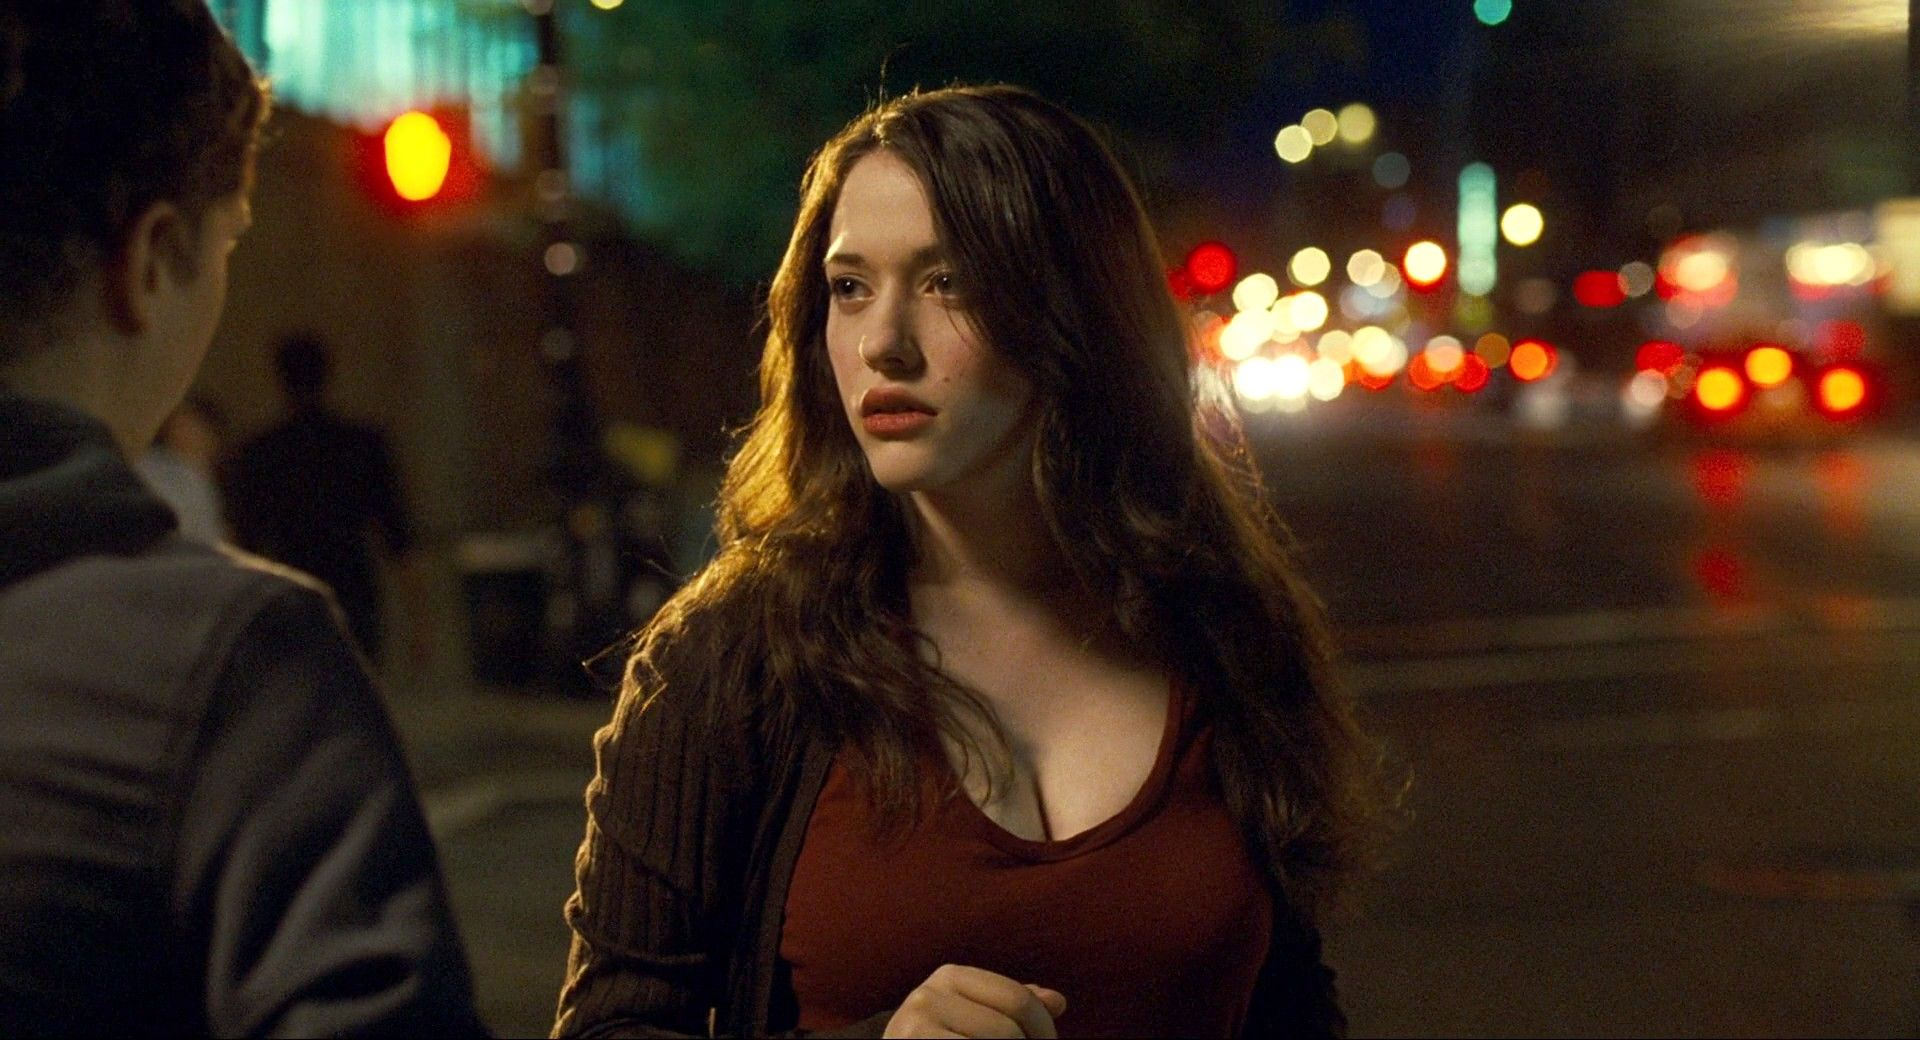What story or narrative could be unfolding here? The image could be part of a narrative where the young woman is at a crossroads in her life. She might be waiting for a loved one or contemplating a pivotal decision. The vibrant night scene around her contrasts with her stillness, emphasizing her inner conflict or anticipation. The bright red of her top against the muted colors of the city suggests she might be experiencing a moment of personal significance in an otherwise ordinary setting. Can you imagine a dramatic plot twist in this narrative? Absolutely! Imagine that as she stands there, deep in thought, a sudden sound draws her attention – a car screeches to a halt and someone she thought she would never see again steps out. This unexpected reunion could change the course of her evening entirely, introducing elements of surprise and emotion into the unfolding story. Maybe this person brings important news or a dramatic revelation that will change her life forever. 